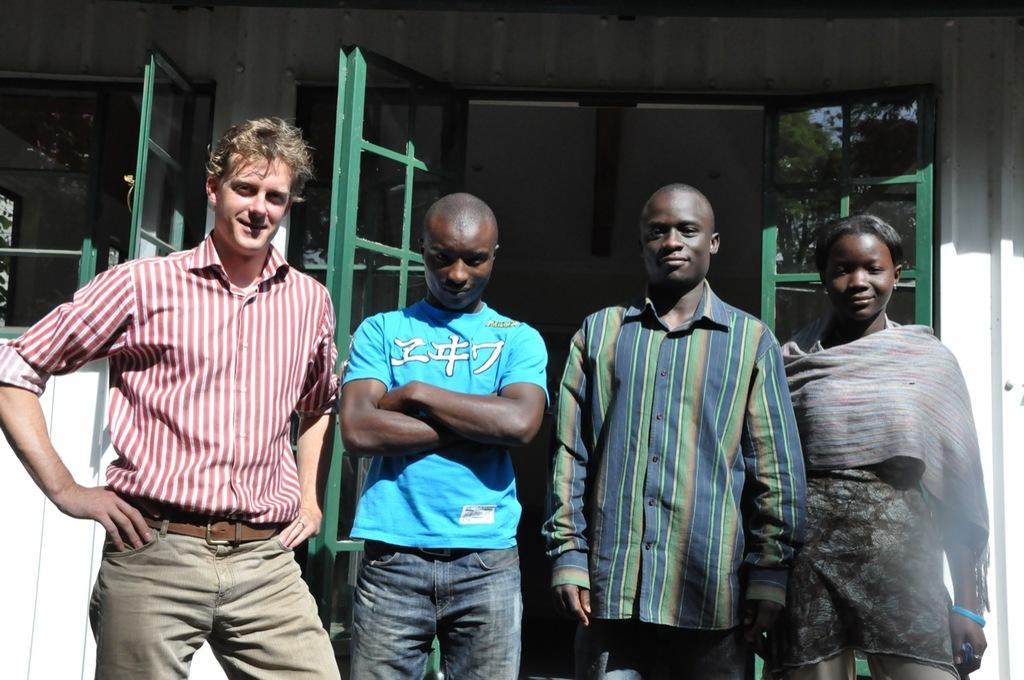Could you give a brief overview of what you see in this image? In the image there are four people standing in front of a door and posing for the photo. 